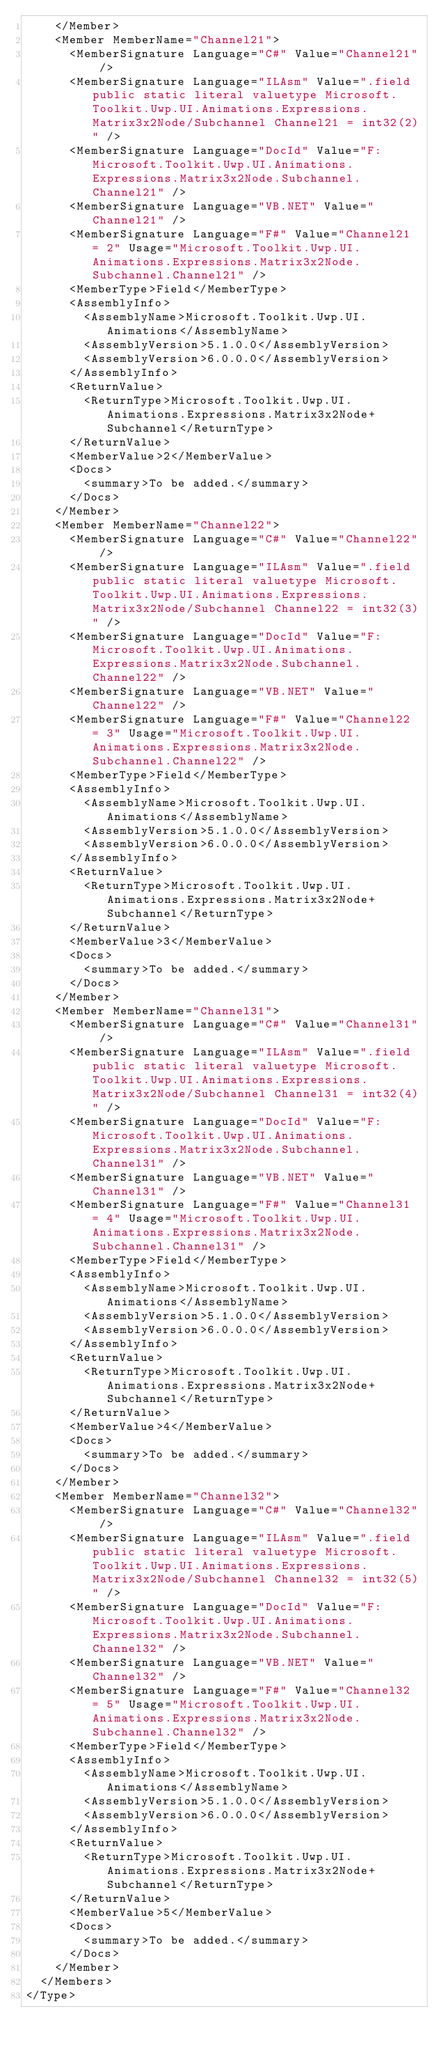Convert code to text. <code><loc_0><loc_0><loc_500><loc_500><_XML_>    </Member>
    <Member MemberName="Channel21">
      <MemberSignature Language="C#" Value="Channel21" />
      <MemberSignature Language="ILAsm" Value=".field public static literal valuetype Microsoft.Toolkit.Uwp.UI.Animations.Expressions.Matrix3x2Node/Subchannel Channel21 = int32(2)" />
      <MemberSignature Language="DocId" Value="F:Microsoft.Toolkit.Uwp.UI.Animations.Expressions.Matrix3x2Node.Subchannel.Channel21" />
      <MemberSignature Language="VB.NET" Value="Channel21" />
      <MemberSignature Language="F#" Value="Channel21 = 2" Usage="Microsoft.Toolkit.Uwp.UI.Animations.Expressions.Matrix3x2Node.Subchannel.Channel21" />
      <MemberType>Field</MemberType>
      <AssemblyInfo>
        <AssemblyName>Microsoft.Toolkit.Uwp.UI.Animations</AssemblyName>
        <AssemblyVersion>5.1.0.0</AssemblyVersion>
        <AssemblyVersion>6.0.0.0</AssemblyVersion>
      </AssemblyInfo>
      <ReturnValue>
        <ReturnType>Microsoft.Toolkit.Uwp.UI.Animations.Expressions.Matrix3x2Node+Subchannel</ReturnType>
      </ReturnValue>
      <MemberValue>2</MemberValue>
      <Docs>
        <summary>To be added.</summary>
      </Docs>
    </Member>
    <Member MemberName="Channel22">
      <MemberSignature Language="C#" Value="Channel22" />
      <MemberSignature Language="ILAsm" Value=".field public static literal valuetype Microsoft.Toolkit.Uwp.UI.Animations.Expressions.Matrix3x2Node/Subchannel Channel22 = int32(3)" />
      <MemberSignature Language="DocId" Value="F:Microsoft.Toolkit.Uwp.UI.Animations.Expressions.Matrix3x2Node.Subchannel.Channel22" />
      <MemberSignature Language="VB.NET" Value="Channel22" />
      <MemberSignature Language="F#" Value="Channel22 = 3" Usage="Microsoft.Toolkit.Uwp.UI.Animations.Expressions.Matrix3x2Node.Subchannel.Channel22" />
      <MemberType>Field</MemberType>
      <AssemblyInfo>
        <AssemblyName>Microsoft.Toolkit.Uwp.UI.Animations</AssemblyName>
        <AssemblyVersion>5.1.0.0</AssemblyVersion>
        <AssemblyVersion>6.0.0.0</AssemblyVersion>
      </AssemblyInfo>
      <ReturnValue>
        <ReturnType>Microsoft.Toolkit.Uwp.UI.Animations.Expressions.Matrix3x2Node+Subchannel</ReturnType>
      </ReturnValue>
      <MemberValue>3</MemberValue>
      <Docs>
        <summary>To be added.</summary>
      </Docs>
    </Member>
    <Member MemberName="Channel31">
      <MemberSignature Language="C#" Value="Channel31" />
      <MemberSignature Language="ILAsm" Value=".field public static literal valuetype Microsoft.Toolkit.Uwp.UI.Animations.Expressions.Matrix3x2Node/Subchannel Channel31 = int32(4)" />
      <MemberSignature Language="DocId" Value="F:Microsoft.Toolkit.Uwp.UI.Animations.Expressions.Matrix3x2Node.Subchannel.Channel31" />
      <MemberSignature Language="VB.NET" Value="Channel31" />
      <MemberSignature Language="F#" Value="Channel31 = 4" Usage="Microsoft.Toolkit.Uwp.UI.Animations.Expressions.Matrix3x2Node.Subchannel.Channel31" />
      <MemberType>Field</MemberType>
      <AssemblyInfo>
        <AssemblyName>Microsoft.Toolkit.Uwp.UI.Animations</AssemblyName>
        <AssemblyVersion>5.1.0.0</AssemblyVersion>
        <AssemblyVersion>6.0.0.0</AssemblyVersion>
      </AssemblyInfo>
      <ReturnValue>
        <ReturnType>Microsoft.Toolkit.Uwp.UI.Animations.Expressions.Matrix3x2Node+Subchannel</ReturnType>
      </ReturnValue>
      <MemberValue>4</MemberValue>
      <Docs>
        <summary>To be added.</summary>
      </Docs>
    </Member>
    <Member MemberName="Channel32">
      <MemberSignature Language="C#" Value="Channel32" />
      <MemberSignature Language="ILAsm" Value=".field public static literal valuetype Microsoft.Toolkit.Uwp.UI.Animations.Expressions.Matrix3x2Node/Subchannel Channel32 = int32(5)" />
      <MemberSignature Language="DocId" Value="F:Microsoft.Toolkit.Uwp.UI.Animations.Expressions.Matrix3x2Node.Subchannel.Channel32" />
      <MemberSignature Language="VB.NET" Value="Channel32" />
      <MemberSignature Language="F#" Value="Channel32 = 5" Usage="Microsoft.Toolkit.Uwp.UI.Animations.Expressions.Matrix3x2Node.Subchannel.Channel32" />
      <MemberType>Field</MemberType>
      <AssemblyInfo>
        <AssemblyName>Microsoft.Toolkit.Uwp.UI.Animations</AssemblyName>
        <AssemblyVersion>5.1.0.0</AssemblyVersion>
        <AssemblyVersion>6.0.0.0</AssemblyVersion>
      </AssemblyInfo>
      <ReturnValue>
        <ReturnType>Microsoft.Toolkit.Uwp.UI.Animations.Expressions.Matrix3x2Node+Subchannel</ReturnType>
      </ReturnValue>
      <MemberValue>5</MemberValue>
      <Docs>
        <summary>To be added.</summary>
      </Docs>
    </Member>
  </Members>
</Type>
</code> 